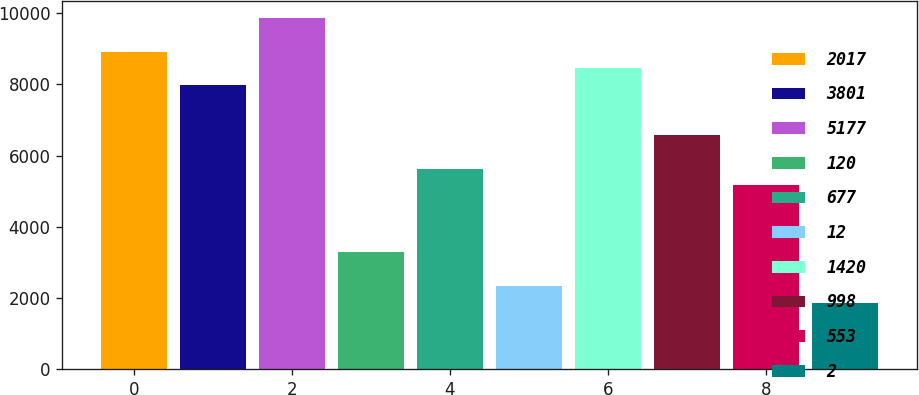Convert chart to OTSL. <chart><loc_0><loc_0><loc_500><loc_500><bar_chart><fcel>2017<fcel>3801<fcel>5177<fcel>120<fcel>677<fcel>12<fcel>1420<fcel>998<fcel>553<fcel>2<nl><fcel>8917.52<fcel>7978.96<fcel>9856.08<fcel>3286.16<fcel>5632.56<fcel>2347.6<fcel>8448.24<fcel>6571.12<fcel>5163.28<fcel>1878.32<nl></chart> 